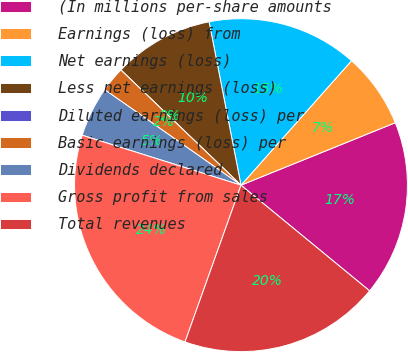Convert chart. <chart><loc_0><loc_0><loc_500><loc_500><pie_chart><fcel>(In millions per-share amounts<fcel>Earnings (loss) from<fcel>Net earnings (loss)<fcel>Less net earnings (loss)<fcel>Diluted earnings (loss) per<fcel>Basic earnings (loss) per<fcel>Dividends declared<fcel>Gross profit from sales<fcel>Total revenues<nl><fcel>17.07%<fcel>7.32%<fcel>14.63%<fcel>9.76%<fcel>0.0%<fcel>2.44%<fcel>4.88%<fcel>24.39%<fcel>19.51%<nl></chart> 